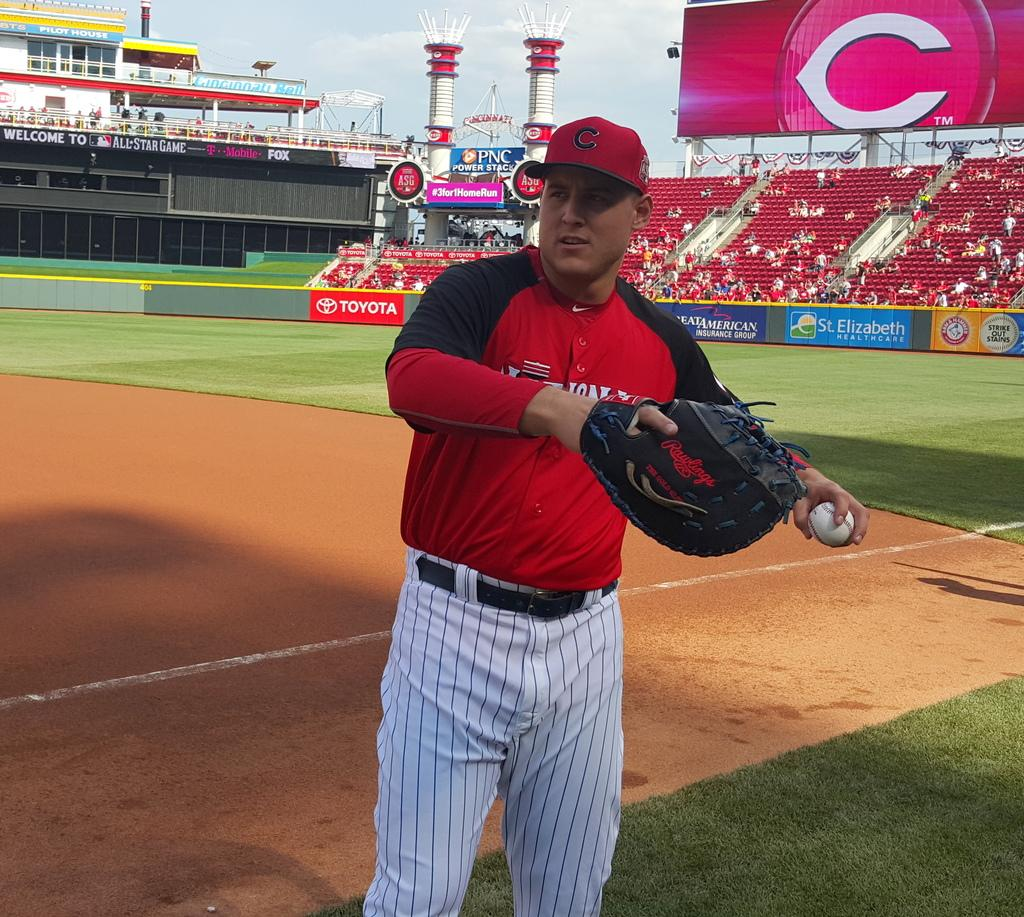<image>
Give a short and clear explanation of the subsequent image. Pilot house in the background of the reds stadium 